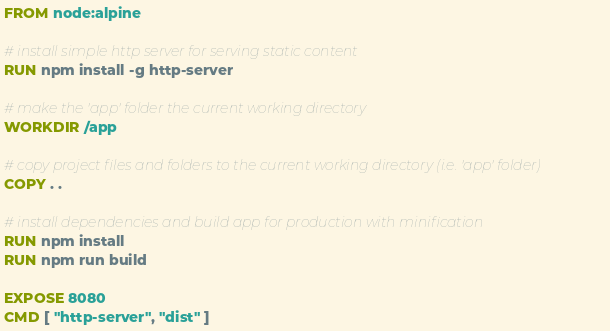Convert code to text. <code><loc_0><loc_0><loc_500><loc_500><_Dockerfile_>FROM node:alpine

# install simple http server for serving static content
RUN npm install -g http-server

# make the 'app' folder the current working directory
WORKDIR /app

# copy project files and folders to the current working directory (i.e. 'app' folder)
COPY . .

# install dependencies and build app for production with minification
RUN npm install
RUN npm run build

EXPOSE 8080
CMD [ "http-server", "dist" ]
</code> 